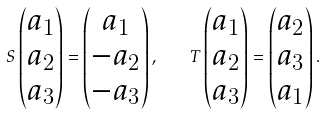<formula> <loc_0><loc_0><loc_500><loc_500>S \begin{pmatrix} a _ { 1 } \\ a _ { 2 } \\ a _ { 3 } \end{pmatrix} = \begin{pmatrix} a _ { 1 } \\ - a _ { 2 } \\ - a _ { 3 } \end{pmatrix} , \quad T \begin{pmatrix} a _ { 1 } \\ a _ { 2 } \\ a _ { 3 } \end{pmatrix} = \begin{pmatrix} a _ { 2 } \\ a _ { 3 } \\ a _ { 1 } \end{pmatrix} .</formula> 